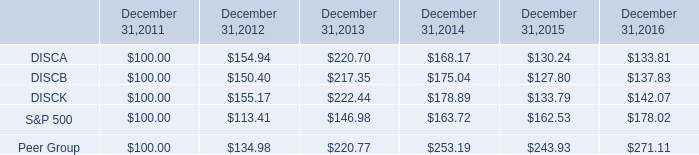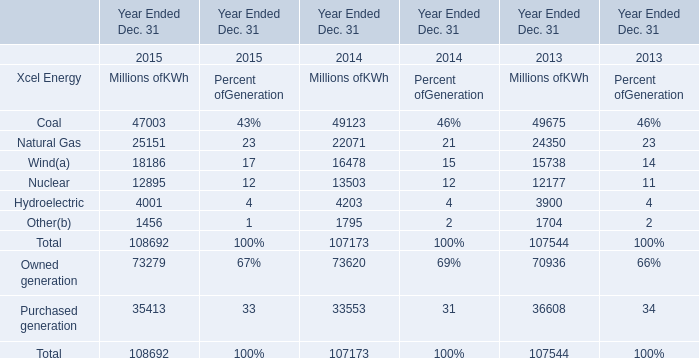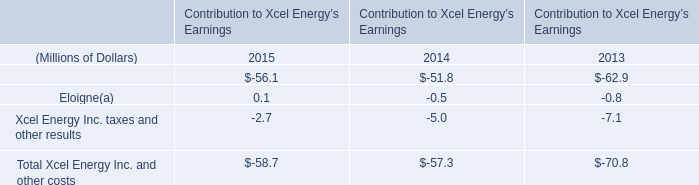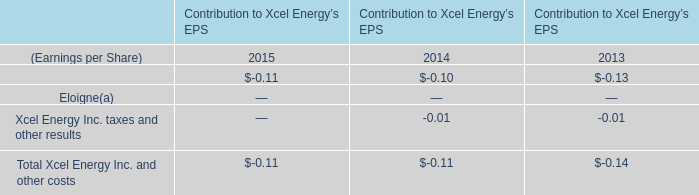What is the growing rate of Xcel Energy Inc. financing costs in the year with the most Coal of xcel energy? 
Computations: ((-0.1 + 0.13) / -0.13)
Answer: -0.23077. 